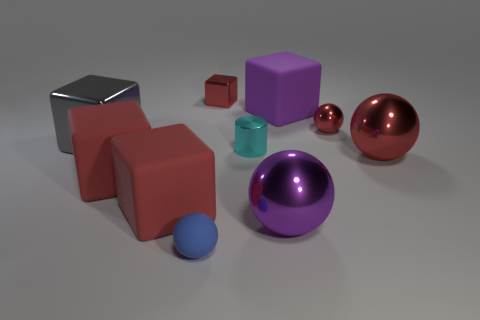Subtract all blue cylinders. How many red balls are left? 2 Subtract all purple blocks. How many blocks are left? 4 Subtract all red shiny cubes. How many cubes are left? 4 Subtract all cyan balls. Subtract all green cylinders. How many balls are left? 4 Subtract all cylinders. How many objects are left? 9 Add 5 small red metal cubes. How many small red metal cubes are left? 6 Add 1 big blue things. How many big blue things exist? 1 Subtract 2 red spheres. How many objects are left? 8 Subtract all shiny cylinders. Subtract all big red blocks. How many objects are left? 7 